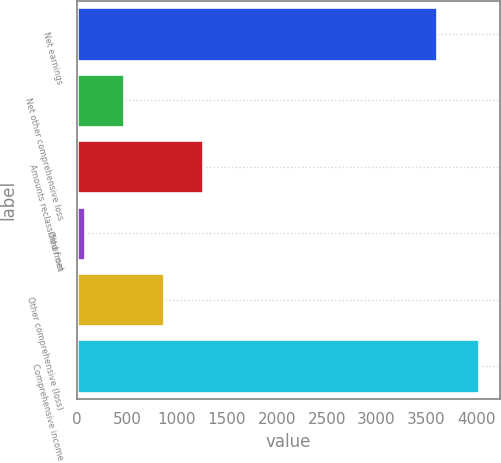<chart> <loc_0><loc_0><loc_500><loc_500><bar_chart><fcel>Net earnings<fcel>Net other comprehensive loss<fcel>Amounts reclassified from<fcel>Other net<fcel>Other comprehensive (loss)<fcel>Comprehensive income<nl><fcel>3605<fcel>468.8<fcel>1260.4<fcel>73<fcel>864.6<fcel>4031<nl></chart> 